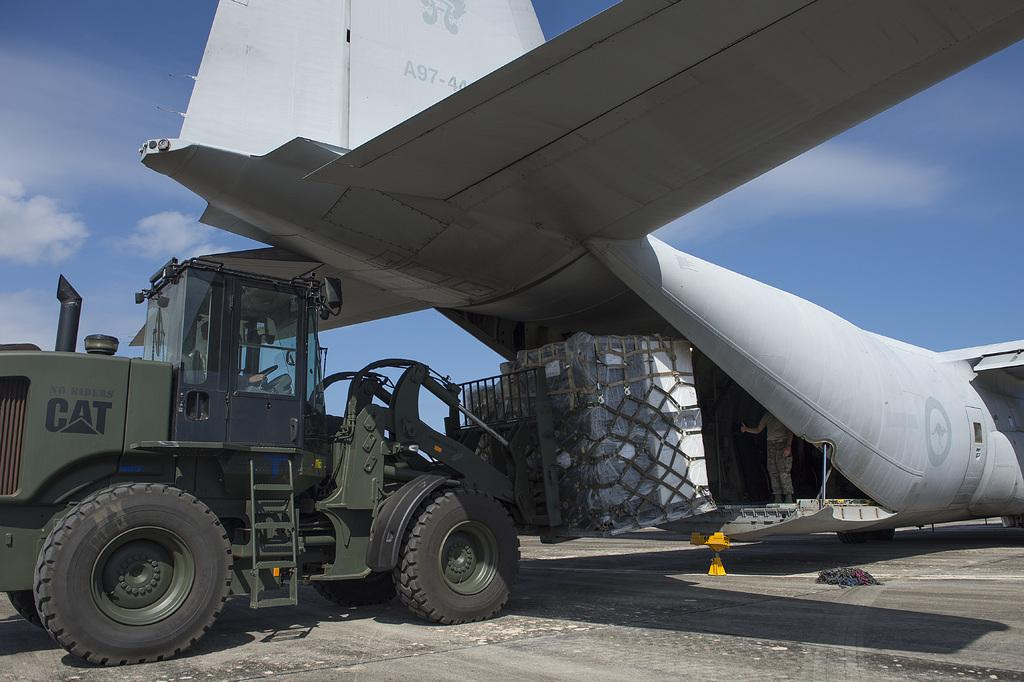What is the main subject in the middle of the image? There is an airplane in the middle of the image. What can be seen on the left side of the image? There is a crane on the left side of the image. What is visible in the background of the image? The sky is visible in the background of the image. What type of oil is being used by the tooth in the image? There is no tooth or oil present in the image. 